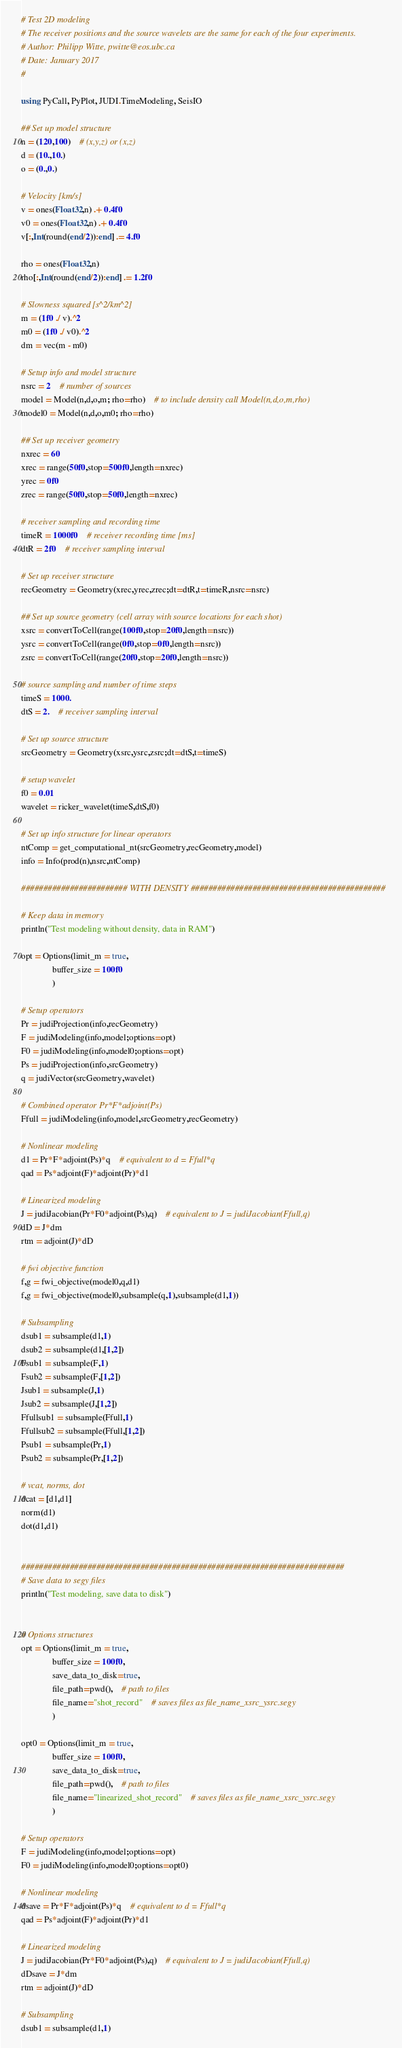Convert code to text. <code><loc_0><loc_0><loc_500><loc_500><_Julia_># Test 2D modeling
# The receiver positions and the source wavelets are the same for each of the four experiments.
# Author: Philipp Witte, pwitte@eos.ubc.ca
# Date: January 2017
#

using PyCall, PyPlot, JUDI.TimeModeling, SeisIO

## Set up model structure
n = (120,100)	# (x,y,z) or (x,z)
d = (10.,10.)
o = (0.,0.)

# Velocity [km/s]
v = ones(Float32,n) .+ 0.4f0
v0 = ones(Float32,n) .+ 0.4f0
v[:,Int(round(end/2)):end] .= 4.f0

rho = ones(Float32,n)
rho[:,Int(round(end/2)):end] .= 1.2f0

# Slowness squared [s^2/km^2]
m = (1f0 ./ v).^2
m0 = (1f0 ./ v0).^2
dm = vec(m - m0)

# Setup info and model structure
nsrc = 2	# number of sources
model = Model(n,d,o,m; rho=rho)	# to include density call Model(n,d,o,m,rho)
model0 = Model(n,d,o,m0; rho=rho)

## Set up receiver geometry
nxrec = 60
xrec = range(50f0,stop=500f0,length=nxrec)
yrec = 0f0
zrec = range(50f0,stop=50f0,length=nxrec)

# receiver sampling and recording time
timeR = 1000f0	# receiver recording time [ms]
dtR = 2f0	# receiver sampling interval

# Set up receiver structure
recGeometry = Geometry(xrec,yrec,zrec;dt=dtR,t=timeR,nsrc=nsrc)

## Set up source geometry (cell array with source locations for each shot)
xsrc = convertToCell(range(100f0,stop=20f0,length=nsrc))
ysrc = convertToCell(range(0f0,stop=0f0,length=nsrc))
zsrc = convertToCell(range(20f0,stop=20f0,length=nsrc))

# source sampling and number of time steps
timeS = 1000.
dtS = 2.	# receiver sampling interval

# Set up source structure
srcGeometry = Geometry(xsrc,ysrc,zsrc;dt=dtS,t=timeS)

# setup wavelet
f0 = 0.01
wavelet = ricker_wavelet(timeS,dtS,f0)

# Set up info structure for linear operators
ntComp = get_computational_nt(srcGeometry,recGeometry,model)
info = Info(prod(n),nsrc,ntComp)

######################## WITH DENSITY ############################################

# Keep data in memory
println("Test modeling without density, data in RAM")

opt = Options(limit_m = true,
              buffer_size = 100f0
			  )

# Setup operators
Pr = judiProjection(info,recGeometry)
F = judiModeling(info,model;options=opt)
F0 = judiModeling(info,model0;options=opt)
Ps = judiProjection(info,srcGeometry)
q = judiVector(srcGeometry,wavelet)

# Combined operator Pr*F*adjoint(Ps)
Ffull = judiModeling(info,model,srcGeometry,recGeometry)

# Nonlinear modeling
d1 = Pr*F*adjoint(Ps)*q	# equivalent to d = Ffull*q
qad = Ps*adjoint(F)*adjoint(Pr)*d1

# Linearized modeling
J = judiJacobian(Pr*F0*adjoint(Ps),q)	# equivalent to J = judiJacobian(Ffull,q)
dD = J*dm
rtm = adjoint(J)*dD

# fwi objective function
f,g = fwi_objective(model0,q,d1)
f,g = fwi_objective(model0,subsample(q,1),subsample(d1,1))

# Subsampling
dsub1 = subsample(d1,1)
dsub2 = subsample(d1,[1,2])
Fsub1 = subsample(F,1)
Fsub2 = subsample(F,[1,2])
Jsub1 = subsample(J,1)
Jsub2 = subsample(J,[1,2])
Ffullsub1 = subsample(Ffull,1)
Ffullsub2 = subsample(Ffull,[1,2])
Psub1 = subsample(Pr,1)
Psub2 = subsample(Pr,[1,2])

# vcat, norms, dot
dcat = [d1,d1]
norm(d1)
dot(d1,d1)


#########################################################################
# Save data to segy files
println("Test modeling, save data to disk")


# Options structures
opt = Options(limit_m = true,
              buffer_size = 100f0,
              save_data_to_disk=true,
			  file_path=pwd(),	# path to files
			  file_name="shot_record"	# saves files as file_name_xsrc_ysrc.segy
			  )

opt0 = Options(limit_m = true,
              buffer_size = 100f0,
              save_data_to_disk=true,
			  file_path=pwd(),	# path to files
			  file_name="linearized_shot_record"	# saves files as file_name_xsrc_ysrc.segy
			  )

# Setup operators
F = judiModeling(info,model;options=opt)
F0 = judiModeling(info,model0;options=opt0)

# Nonlinear modeling
dsave = Pr*F*adjoint(Ps)*q	# equivalent to d = Ffull*q
qad = Ps*adjoint(F)*adjoint(Pr)*d1

# Linearized modeling
J = judiJacobian(Pr*F0*adjoint(Ps),q)	# equivalent to J = judiJacobian(Ffull,q)
dDsave = J*dm
rtm = adjoint(J)*dD

# Subsampling
dsub1 = subsample(d1,1)</code> 